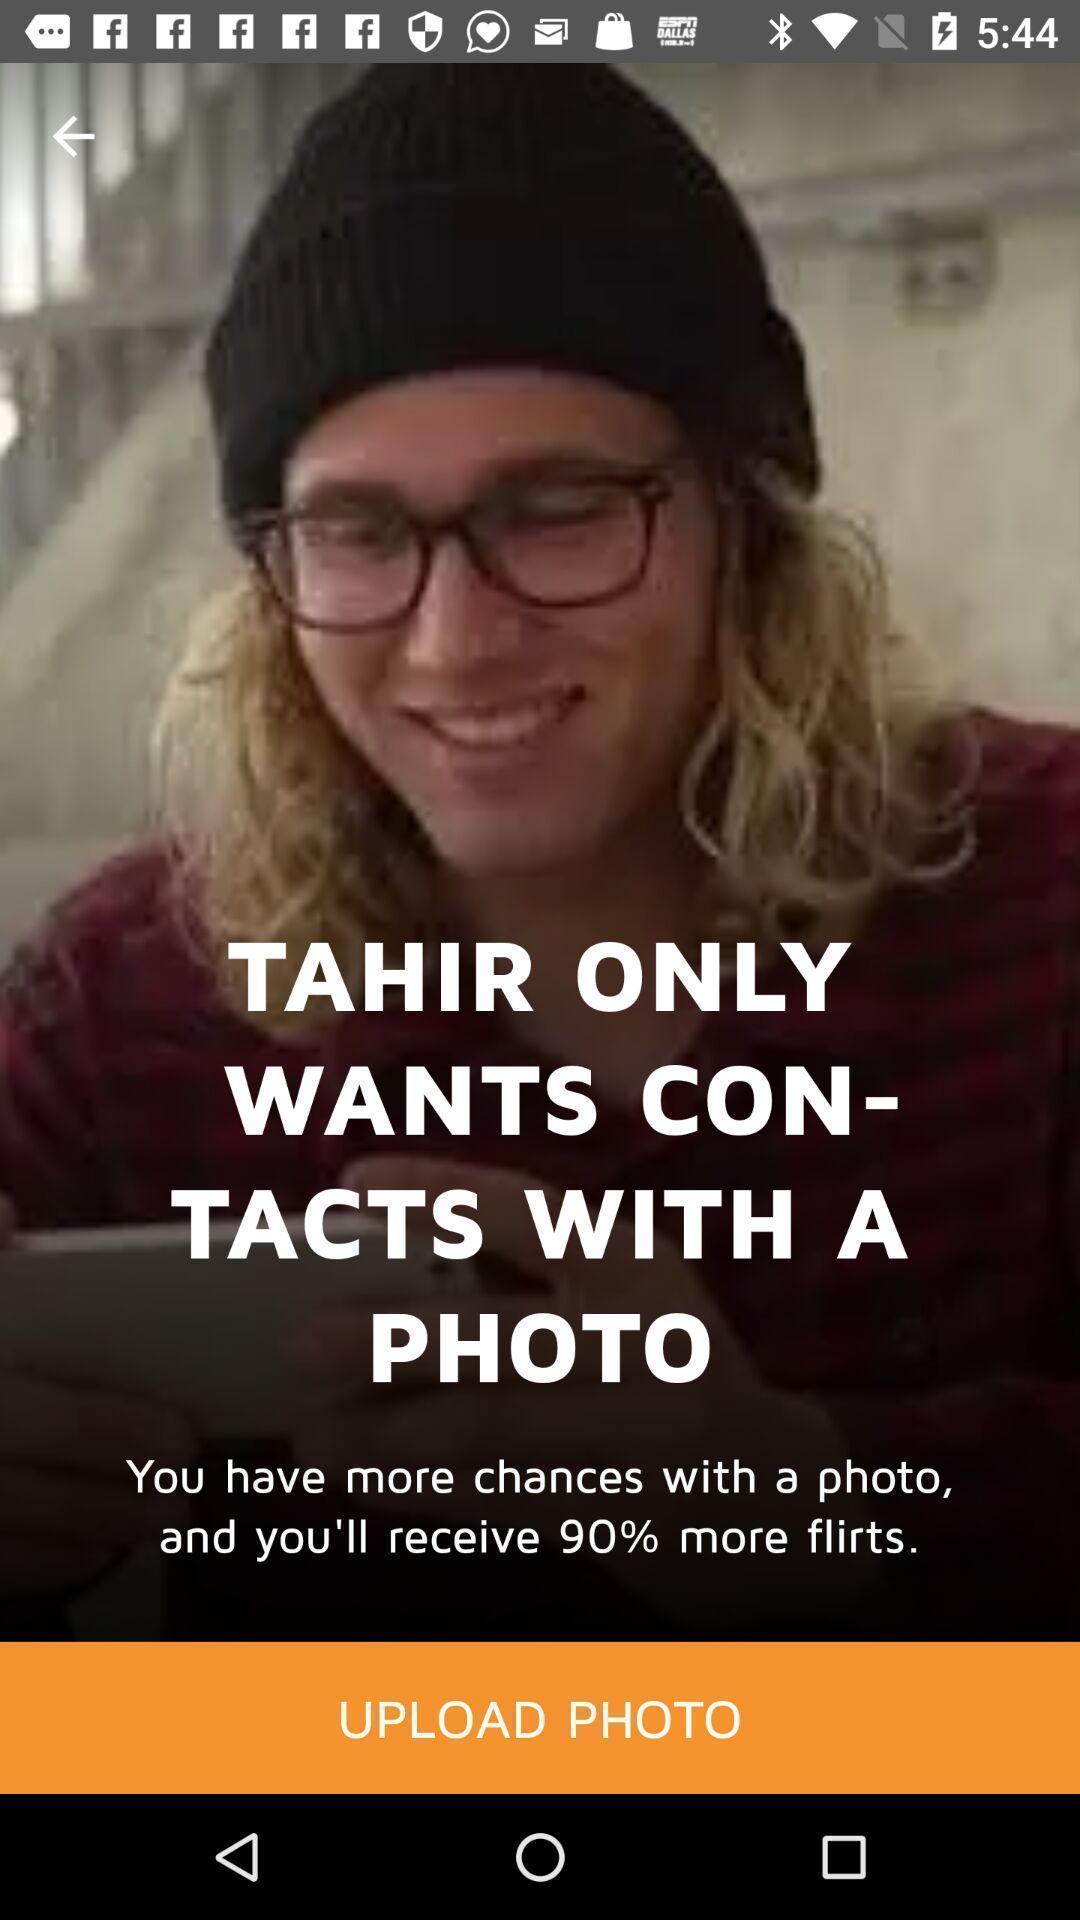Summarize the information in this screenshot. Page to upload photo in the social app. 